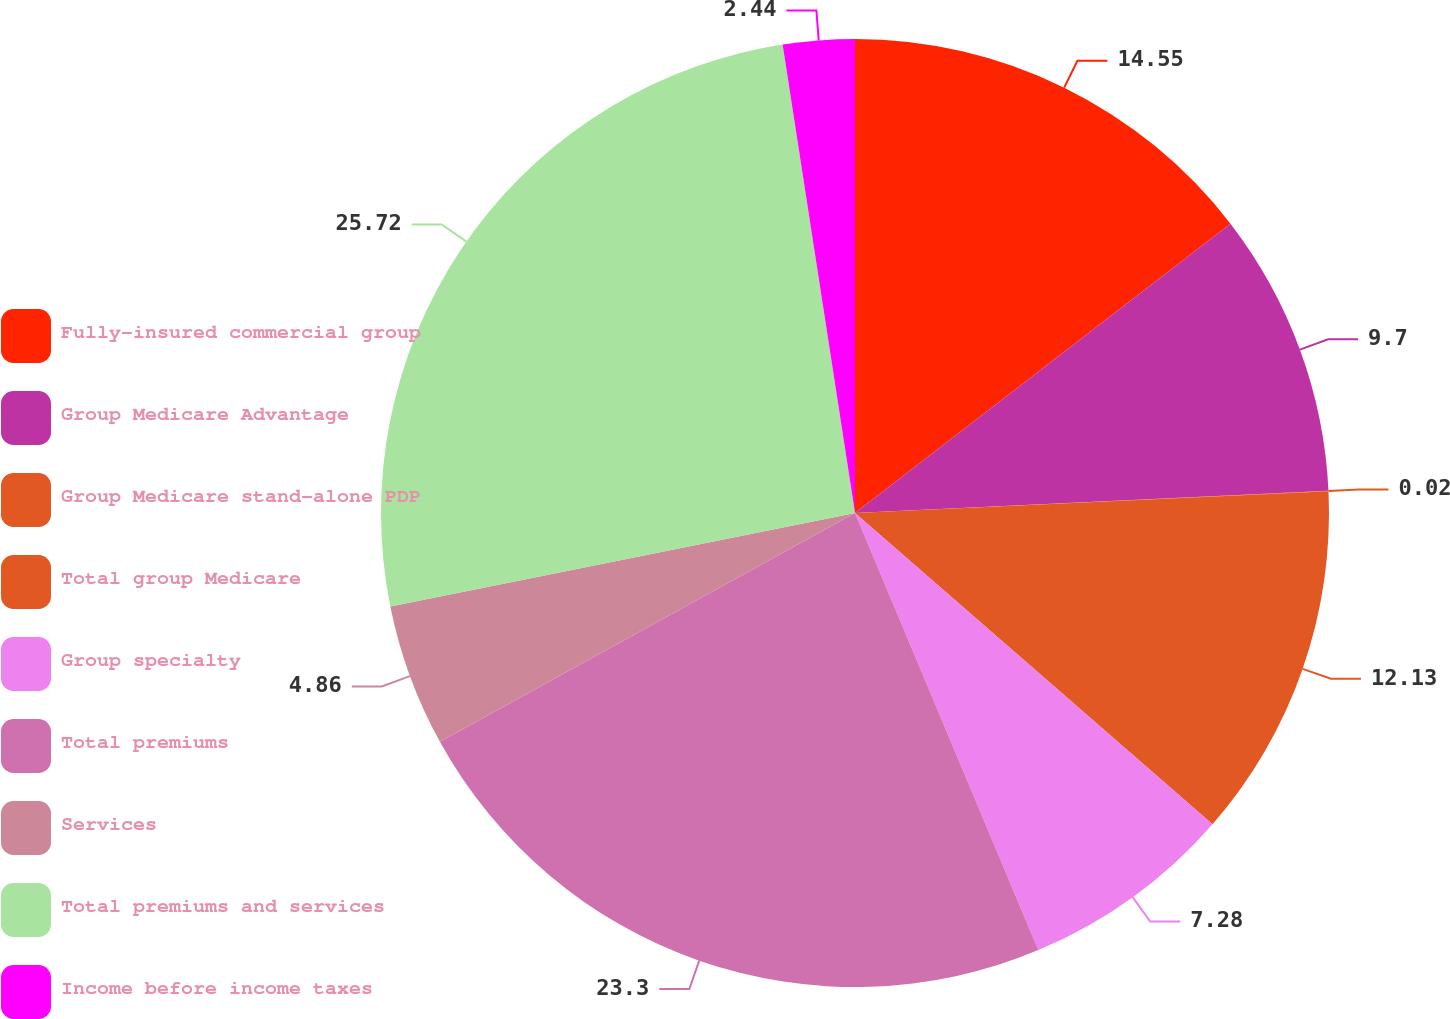Convert chart to OTSL. <chart><loc_0><loc_0><loc_500><loc_500><pie_chart><fcel>Fully-insured commercial group<fcel>Group Medicare Advantage<fcel>Group Medicare stand-alone PDP<fcel>Total group Medicare<fcel>Group specialty<fcel>Total premiums<fcel>Services<fcel>Total premiums and services<fcel>Income before income taxes<nl><fcel>14.55%<fcel>9.7%<fcel>0.02%<fcel>12.13%<fcel>7.28%<fcel>23.3%<fcel>4.86%<fcel>25.72%<fcel>2.44%<nl></chart> 